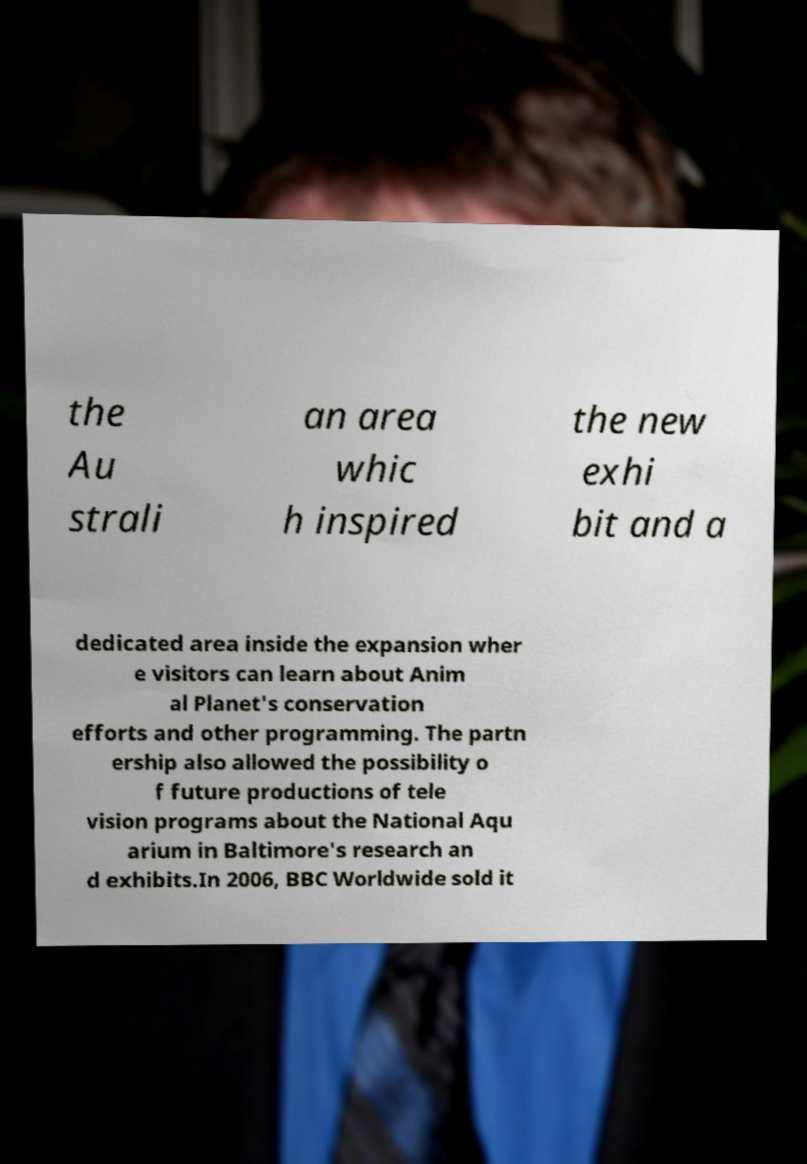I need the written content from this picture converted into text. Can you do that? the Au strali an area whic h inspired the new exhi bit and a dedicated area inside the expansion wher e visitors can learn about Anim al Planet's conservation efforts and other programming. The partn ership also allowed the possibility o f future productions of tele vision programs about the National Aqu arium in Baltimore's research an d exhibits.In 2006, BBC Worldwide sold it 